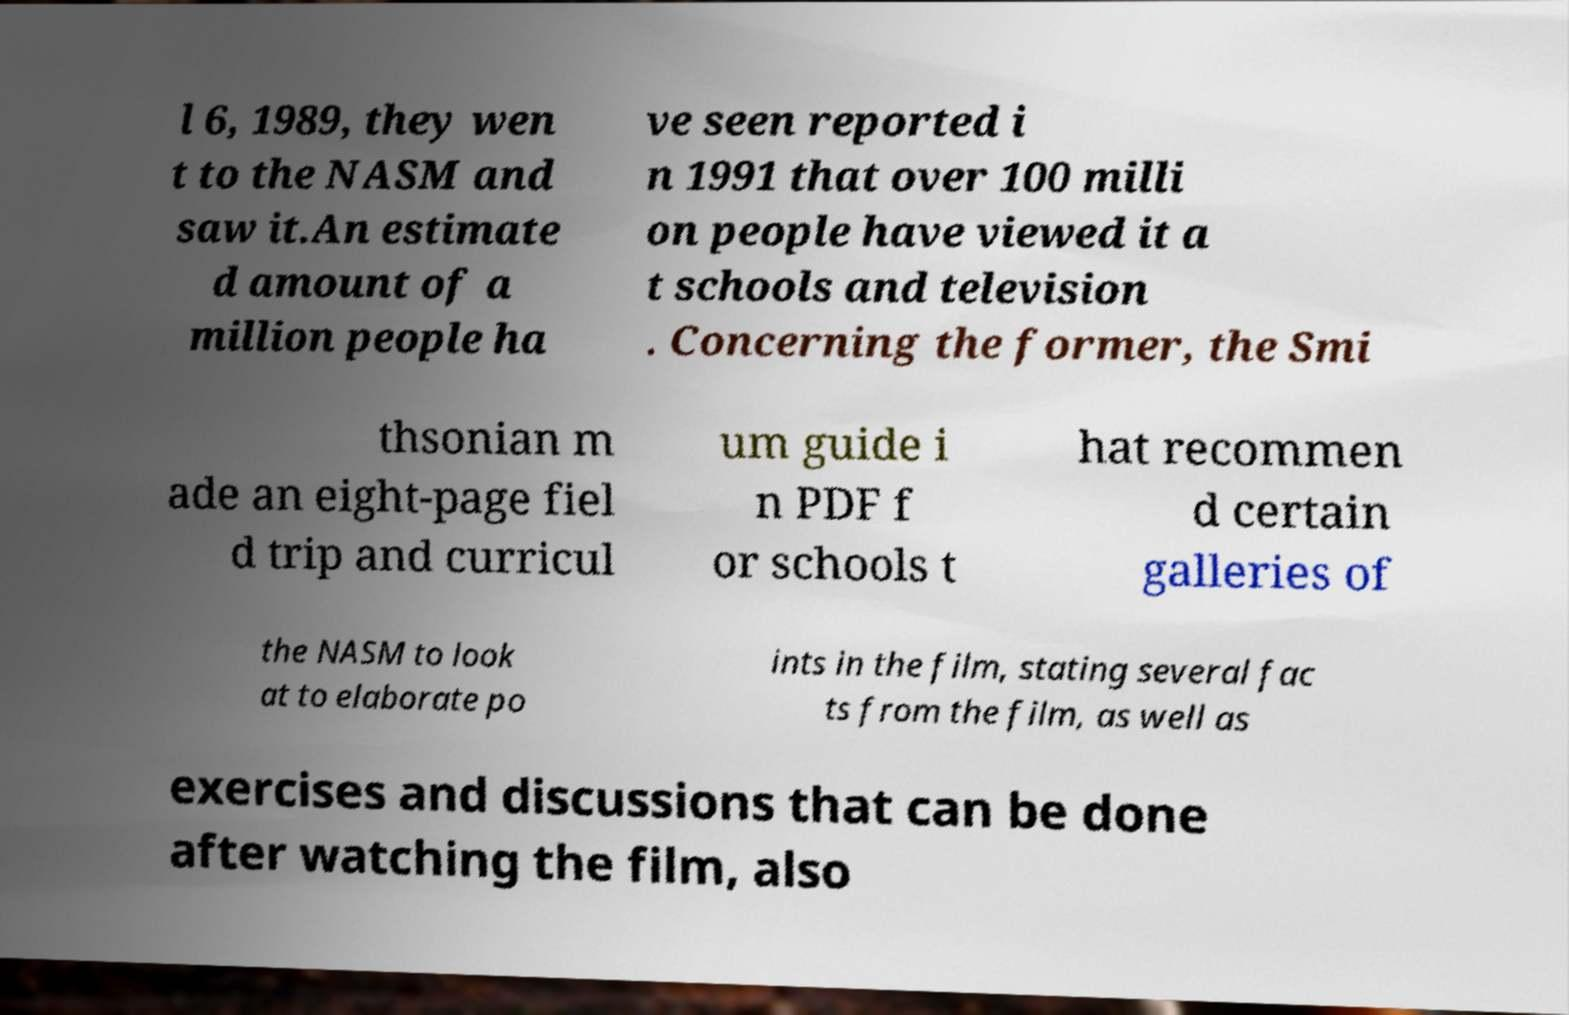I need the written content from this picture converted into text. Can you do that? l 6, 1989, they wen t to the NASM and saw it.An estimate d amount of a million people ha ve seen reported i n 1991 that over 100 milli on people have viewed it a t schools and television . Concerning the former, the Smi thsonian m ade an eight-page fiel d trip and curricul um guide i n PDF f or schools t hat recommen d certain galleries of the NASM to look at to elaborate po ints in the film, stating several fac ts from the film, as well as exercises and discussions that can be done after watching the film, also 